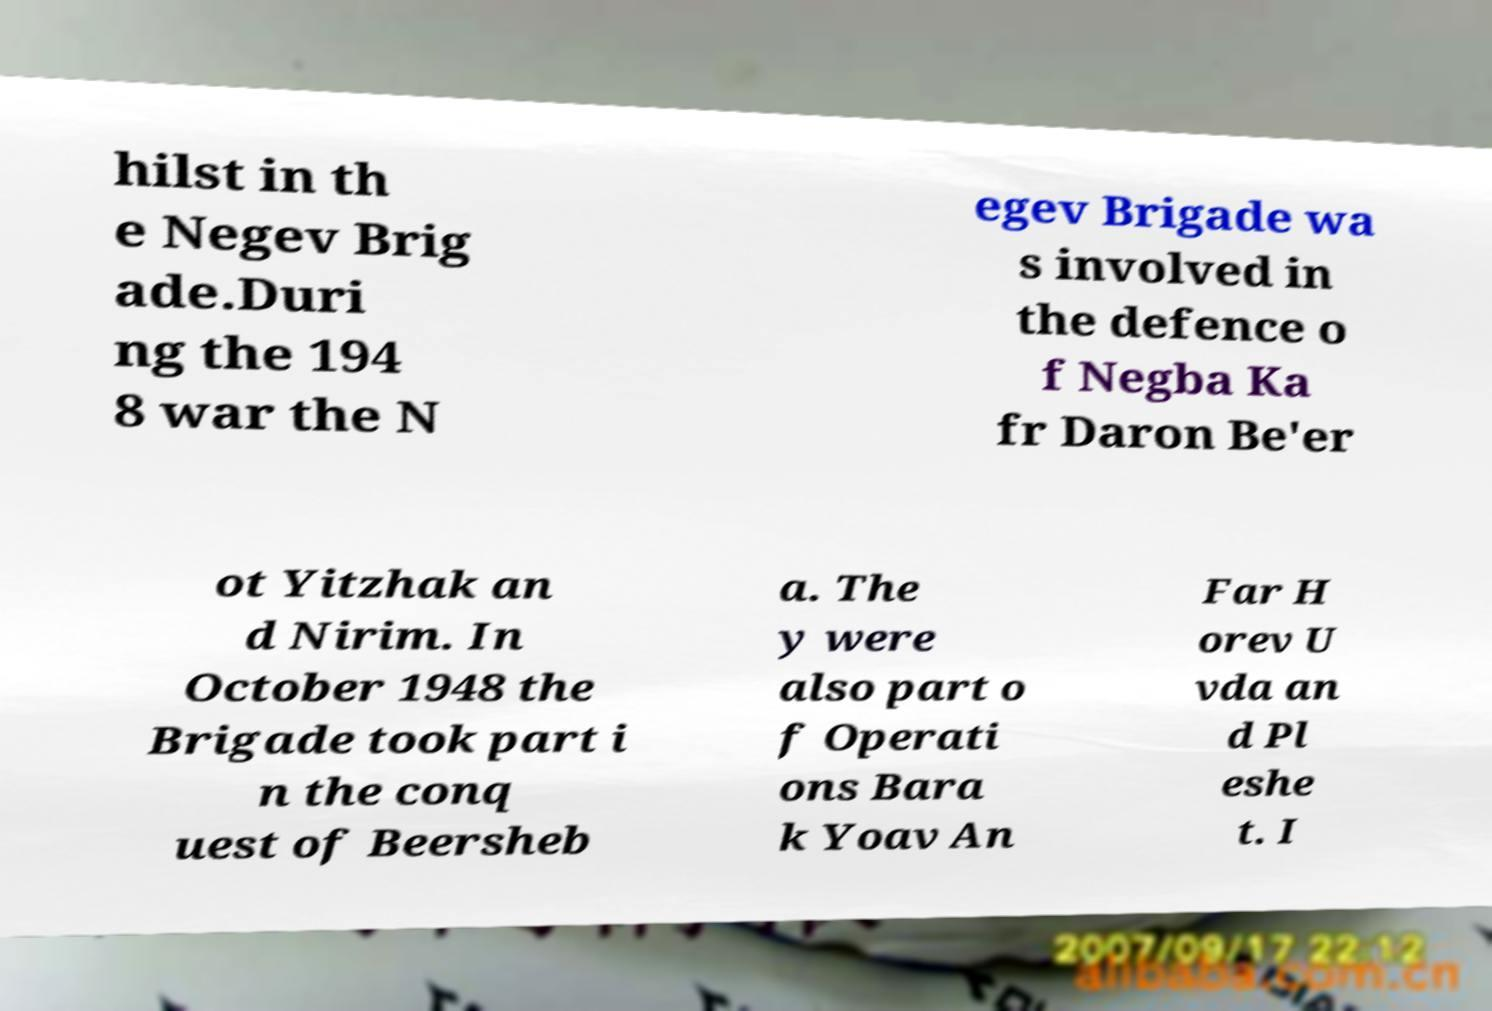What messages or text are displayed in this image? I need them in a readable, typed format. hilst in th e Negev Brig ade.Duri ng the 194 8 war the N egev Brigade wa s involved in the defence o f Negba Ka fr Daron Be'er ot Yitzhak an d Nirim. In October 1948 the Brigade took part i n the conq uest of Beersheb a. The y were also part o f Operati ons Bara k Yoav An Far H orev U vda an d Pl eshe t. I 